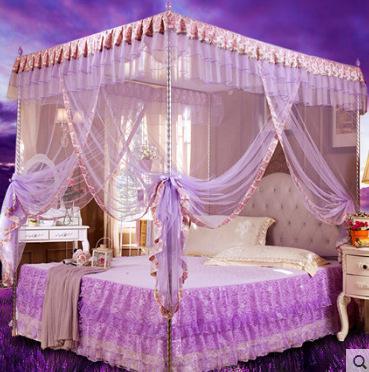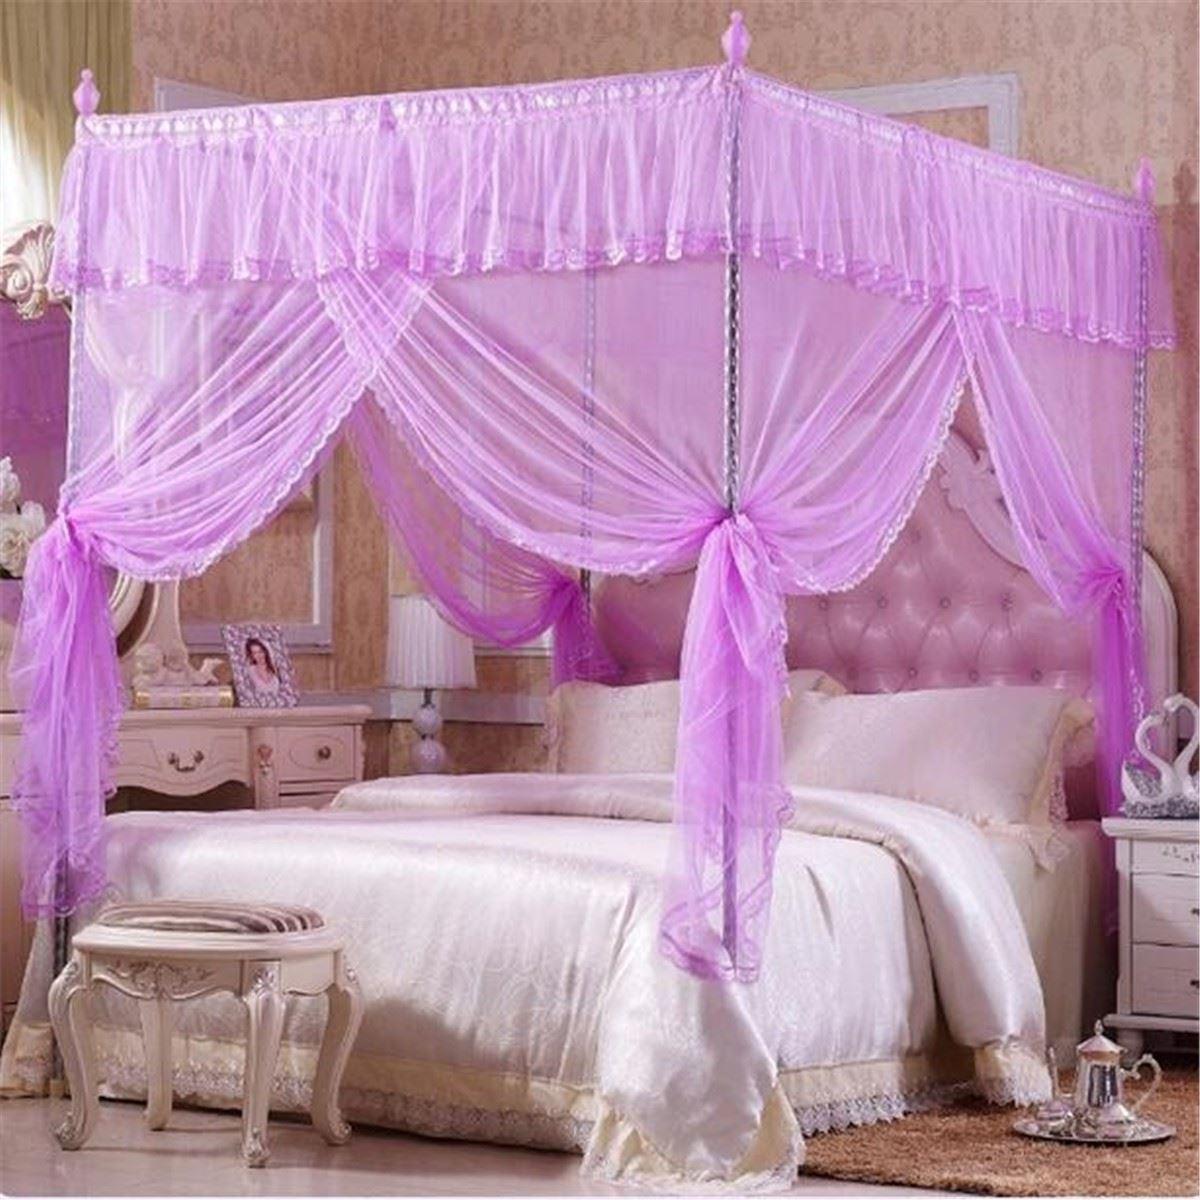The first image is the image on the left, the second image is the image on the right. Evaluate the accuracy of this statement regarding the images: "The bed canopy in the right image is purple.". Is it true? Answer yes or no. Yes. The first image is the image on the left, the second image is the image on the right. Examine the images to the left and right. Is the description "Each bed is covered by a white canape." accurate? Answer yes or no. No. 